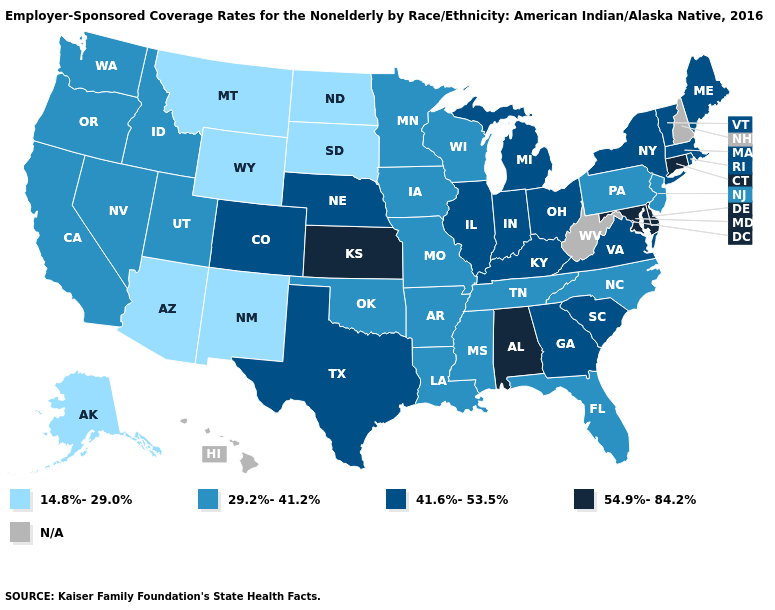Does the first symbol in the legend represent the smallest category?
Be succinct. Yes. What is the value of Georgia?
Short answer required. 41.6%-53.5%. What is the highest value in the West ?
Quick response, please. 41.6%-53.5%. Name the states that have a value in the range 29.2%-41.2%?
Short answer required. Arkansas, California, Florida, Idaho, Iowa, Louisiana, Minnesota, Mississippi, Missouri, Nevada, New Jersey, North Carolina, Oklahoma, Oregon, Pennsylvania, Tennessee, Utah, Washington, Wisconsin. What is the value of Ohio?
Answer briefly. 41.6%-53.5%. Among the states that border Illinois , which have the lowest value?
Write a very short answer. Iowa, Missouri, Wisconsin. Which states hav the highest value in the West?
Keep it brief. Colorado. What is the value of Kansas?
Quick response, please. 54.9%-84.2%. Name the states that have a value in the range 14.8%-29.0%?
Short answer required. Alaska, Arizona, Montana, New Mexico, North Dakota, South Dakota, Wyoming. What is the value of Nebraska?
Quick response, please. 41.6%-53.5%. Among the states that border Wisconsin , does Illinois have the lowest value?
Write a very short answer. No. Does the map have missing data?
Keep it brief. Yes. Name the states that have a value in the range 29.2%-41.2%?
Be succinct. Arkansas, California, Florida, Idaho, Iowa, Louisiana, Minnesota, Mississippi, Missouri, Nevada, New Jersey, North Carolina, Oklahoma, Oregon, Pennsylvania, Tennessee, Utah, Washington, Wisconsin. What is the value of Indiana?
Keep it brief. 41.6%-53.5%. 